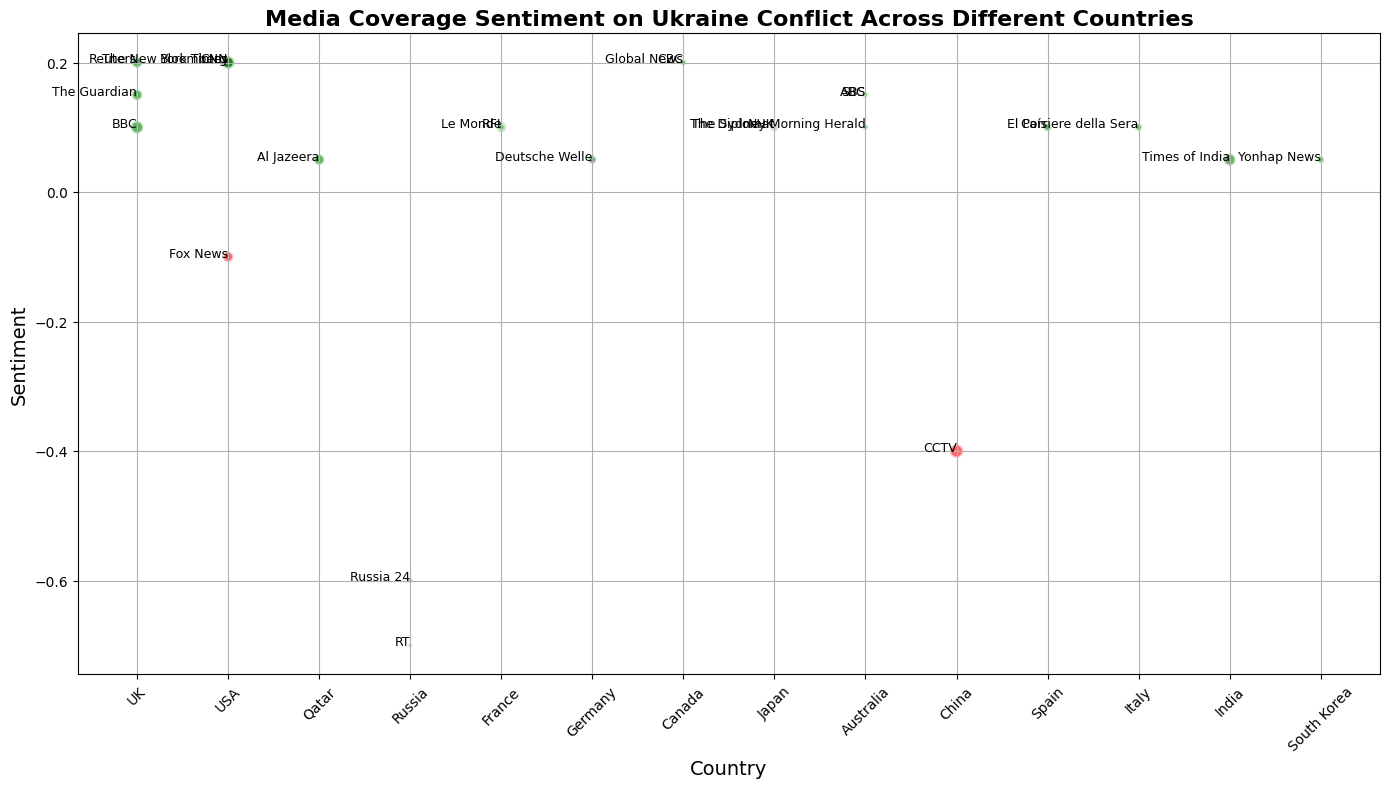What is the sentiment of the outlet with the largest audience reach? The largest audience reach can be determined by looking at the size of the bubbles. Among them, CNN (USA) has the largest bubble, indicating the highest audience reach of 42,000,000. The sentiment for CNN is 0.2.
Answer: 0.2 Which country's outlets have the most positive and most negative sentiments, and what are those sentiments? To find the most positive sentiment, find the highest value on the sentiment axis. To find the most negative sentiment, find the lowest value. The USA's outlets have the most positive sentiment (0.2), and Russia's outlets have the most negative sentiment (-0.7).
Answer: USA: 0.2, Russia: -0.7 Which outlet from the UK shows the highest sentiment? To determine this, scan the graph for outlets from the UK and compare their sentiment values. Reuters and BBC are from the UK, and their sentiments are 0.2 and 0.1, respectively. Reuters shows the highest sentiment at 0.2.
Answer: Reuters Compare the sentiments of Japanese news outlets. Which one has a higher sentiment, and by how much? First, identify the Japanese outlets (NHK and The Diplomat). NHK has a sentiment of 0.1, whereas The Diplomat also has a sentiment value of 0.1. Both have equal sentiments.
Answer: 0.0 What is the average sentiment of all the news outlets in the USA? Calculate the sentiment values of all US outlets (CNN: 0.2, Fox News: -0.1, The New York Times: 0.2, Bloomberg: 0.2). The average can be found by summing these values and dividing by the number of outlets: (0.2 + (-0.1) + 0.2 + 0.2) / 4 = 0.125.
Answer: 0.125 Which outlet has the smallest audience reach, and what is its sentiment? Identify the smallest bubble on the graph, which corresponds to The Diplomat (Japan) with an audience reach of 2,000,000 and a sentiment of 0.1.
Answer: The Diplomat, 0.1 How does the sentiment of China's outlet compare to that of France's outlets? The sentiment of CCTV (China) is -0.4. For France, the outlets are Le Monde and RFI with sentiments of 0.1 each. CCTV's sentiment is lower than both French outlets by a difference of 0.5.
Answer: China: -0.4, France: 0.1, 0.5 Calculate the sum of the audience reaches for the Canadian news outlets. What is the combined sentiment of these outlets? The Canadian outlets are CBC and Global News with audience reaches of 8,000,000 and 6,000,000, respectively. The combined audience reach is 8,000,000 + 6,000,000 = 14,000,000. Both have a sentiment of 0.2, and the combined sentiment, considering both have the same, remains 0.2.
Answer: 14,000,000, 0.2 